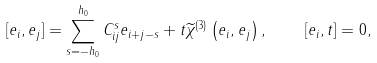<formula> <loc_0><loc_0><loc_500><loc_500>[ e _ { i } , e _ { j } ] = \sum _ { s = - h _ { 0 } } ^ { h _ { 0 } } C _ { i j } ^ { s } e _ { i + j - s } + t \widetilde { \chi } ^ { ( 3 ) } \left ( e _ { i } , e _ { j } \right ) , \quad [ e _ { i } , t ] = 0 ,</formula> 